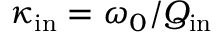Convert formula to latex. <formula><loc_0><loc_0><loc_500><loc_500>\kappa _ { i n } = \omega _ { 0 } / Q _ { i n }</formula> 